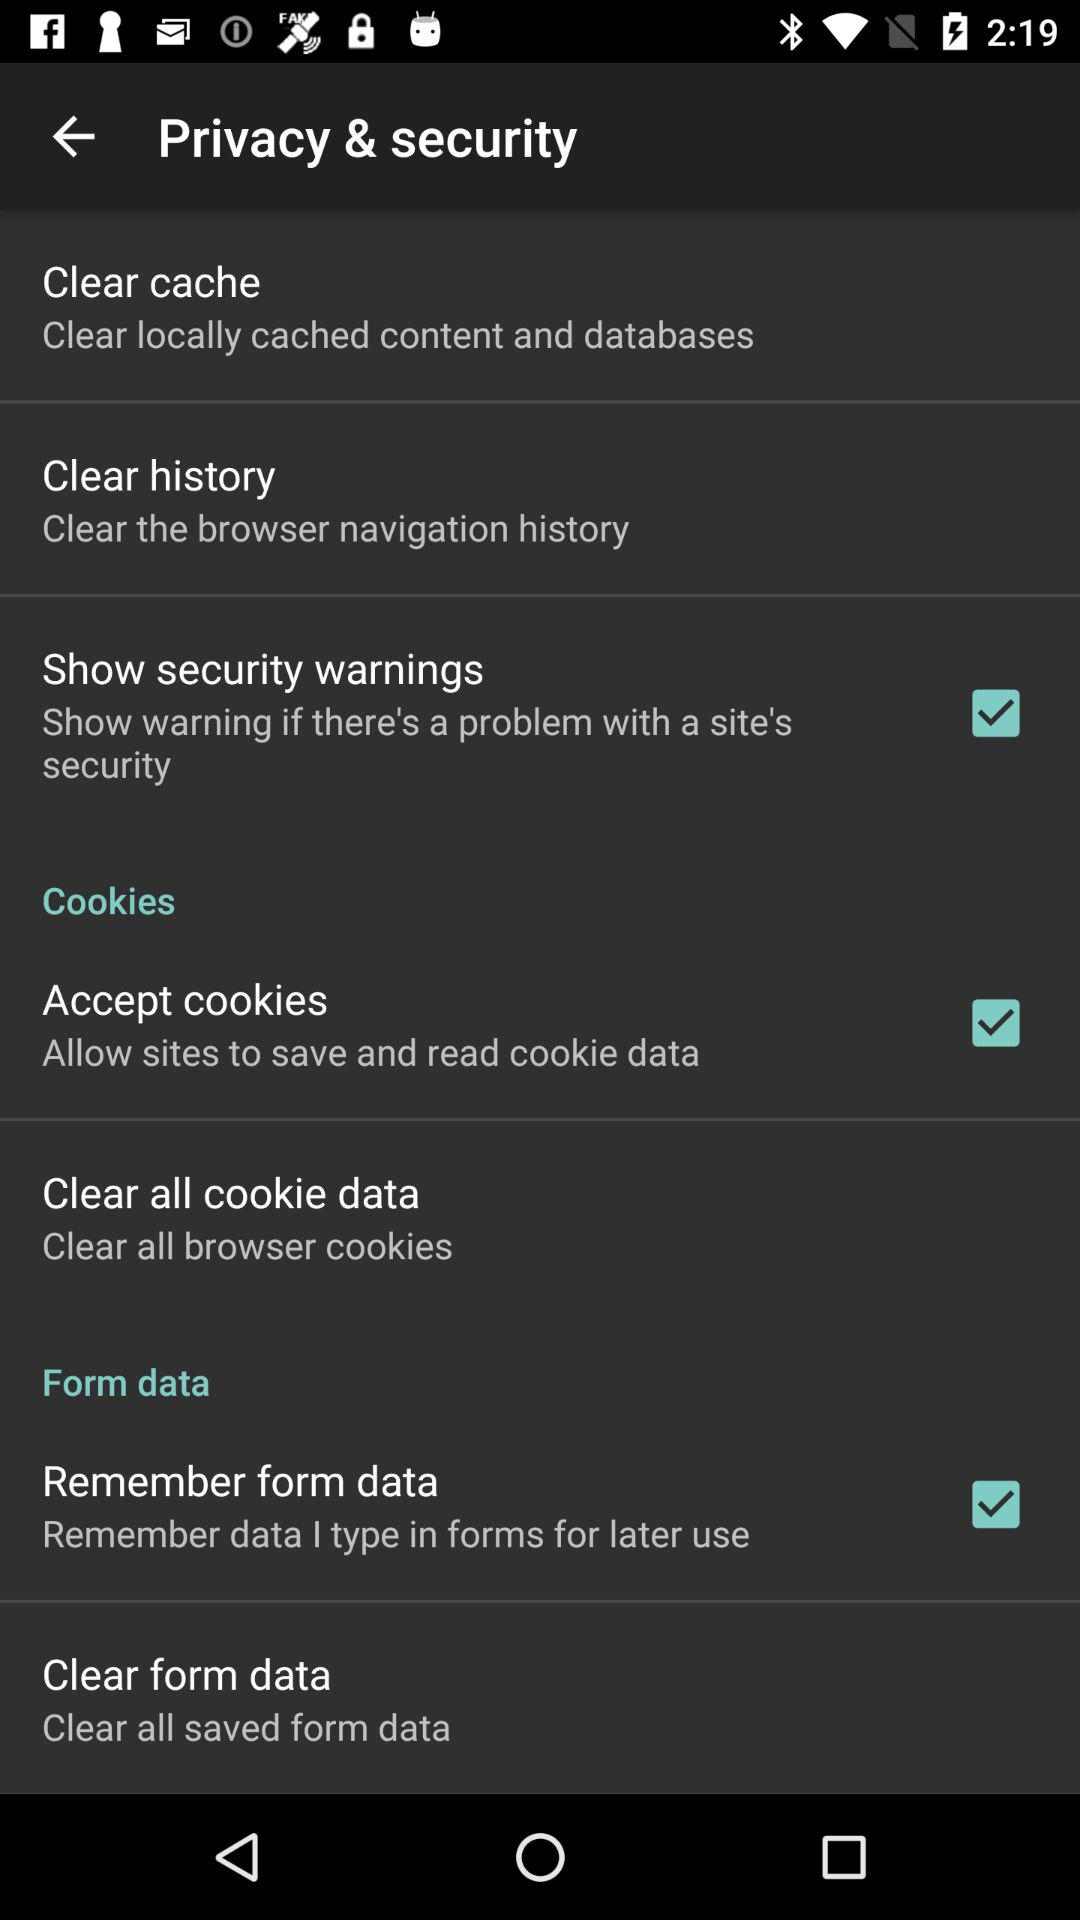What is the status of "Accept cookies"? The status is "on". 